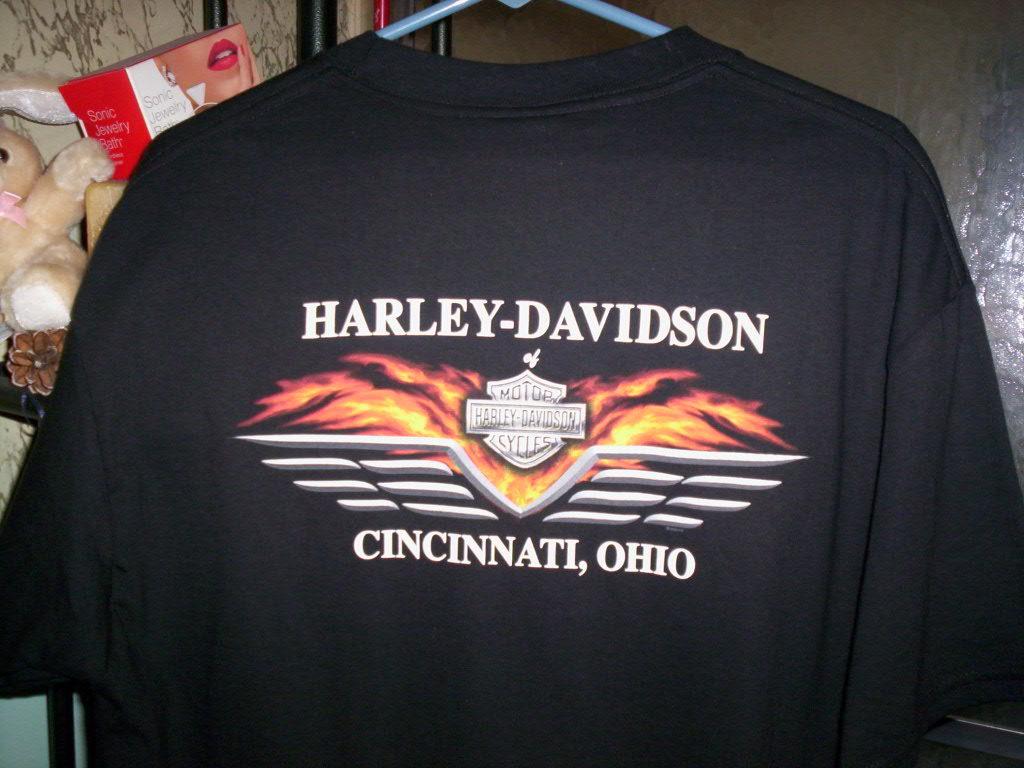What motorcycle brand is shown on the shirt?
Your answer should be compact. Harley davidson. Where is this harley shirt from?
Offer a very short reply. Cincinnati, ohio. 